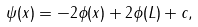<formula> <loc_0><loc_0><loc_500><loc_500>\psi ( x ) = - 2 \phi ( x ) + 2 \phi ( L ) + c ,</formula> 